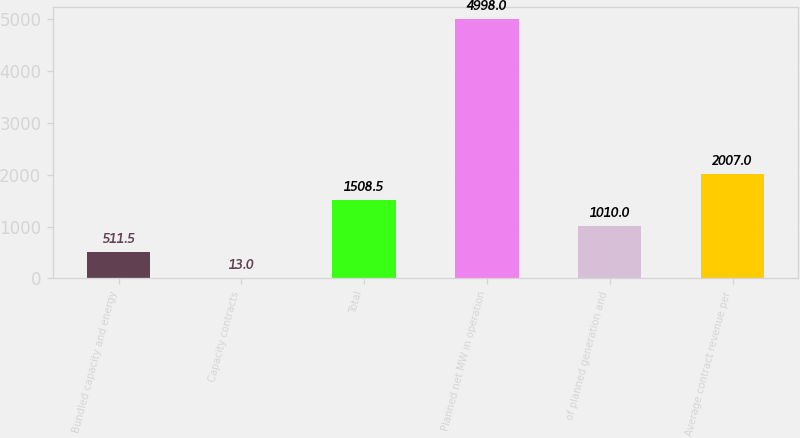Convert chart to OTSL. <chart><loc_0><loc_0><loc_500><loc_500><bar_chart><fcel>Bundled capacity and energy<fcel>Capacity contracts<fcel>Total<fcel>Planned net MW in operation<fcel>of planned generation and<fcel>Average contract revenue per<nl><fcel>511.5<fcel>13<fcel>1508.5<fcel>4998<fcel>1010<fcel>2007<nl></chart> 